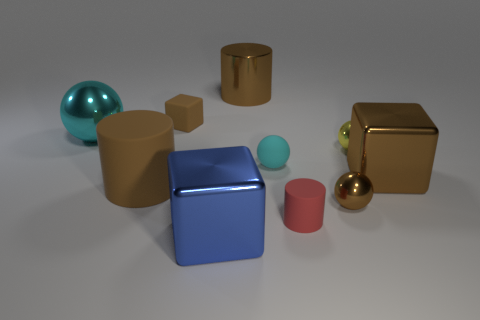Subtract all cylinders. How many objects are left? 7 Add 2 large cyan balls. How many large cyan balls exist? 3 Subtract 0 gray blocks. How many objects are left? 10 Subtract all large metallic cubes. Subtract all large brown shiny objects. How many objects are left? 6 Add 8 red things. How many red things are left? 9 